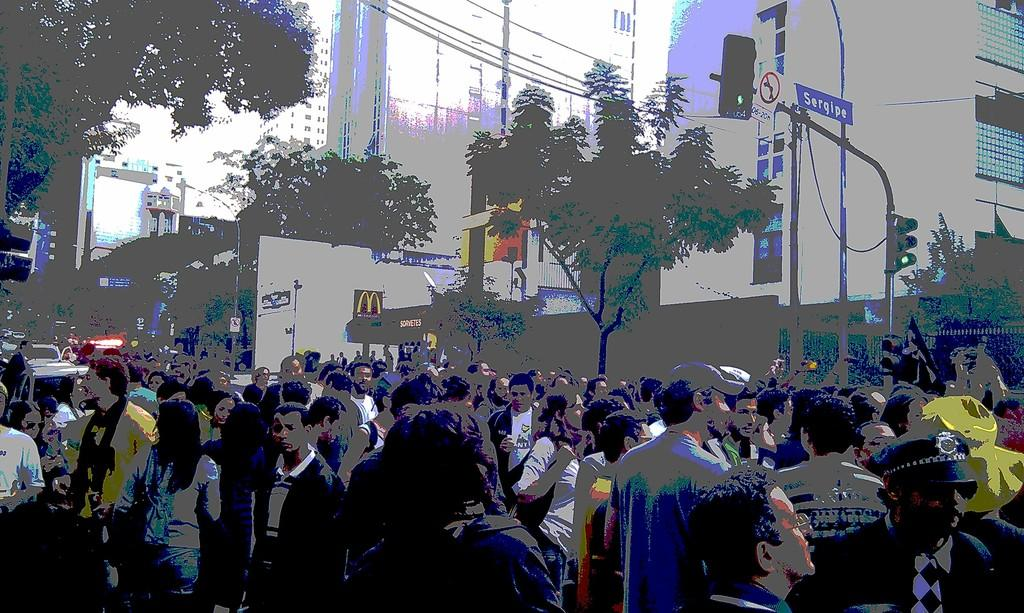What is the main subject of the image? The main subject of the image is a huge crowd. Where is the crowd located in the image? The crowd is standing on the road. What can be seen in the background of the image? There are big buildings and trees in the image. What type of net is being used by the crowd in the image? There is no net present in the image; it features a huge crowd standing on the road with big buildings and trees in the background. 